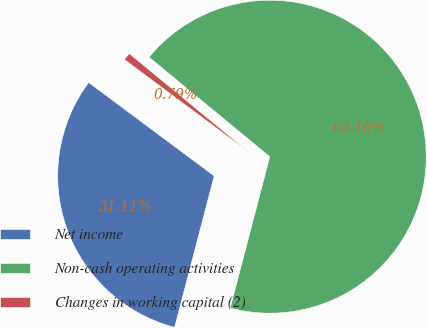<chart> <loc_0><loc_0><loc_500><loc_500><pie_chart><fcel>Net income<fcel>Non-cash operating activities<fcel>Changes in working capital (2)<nl><fcel>31.11%<fcel>68.09%<fcel>0.79%<nl></chart> 